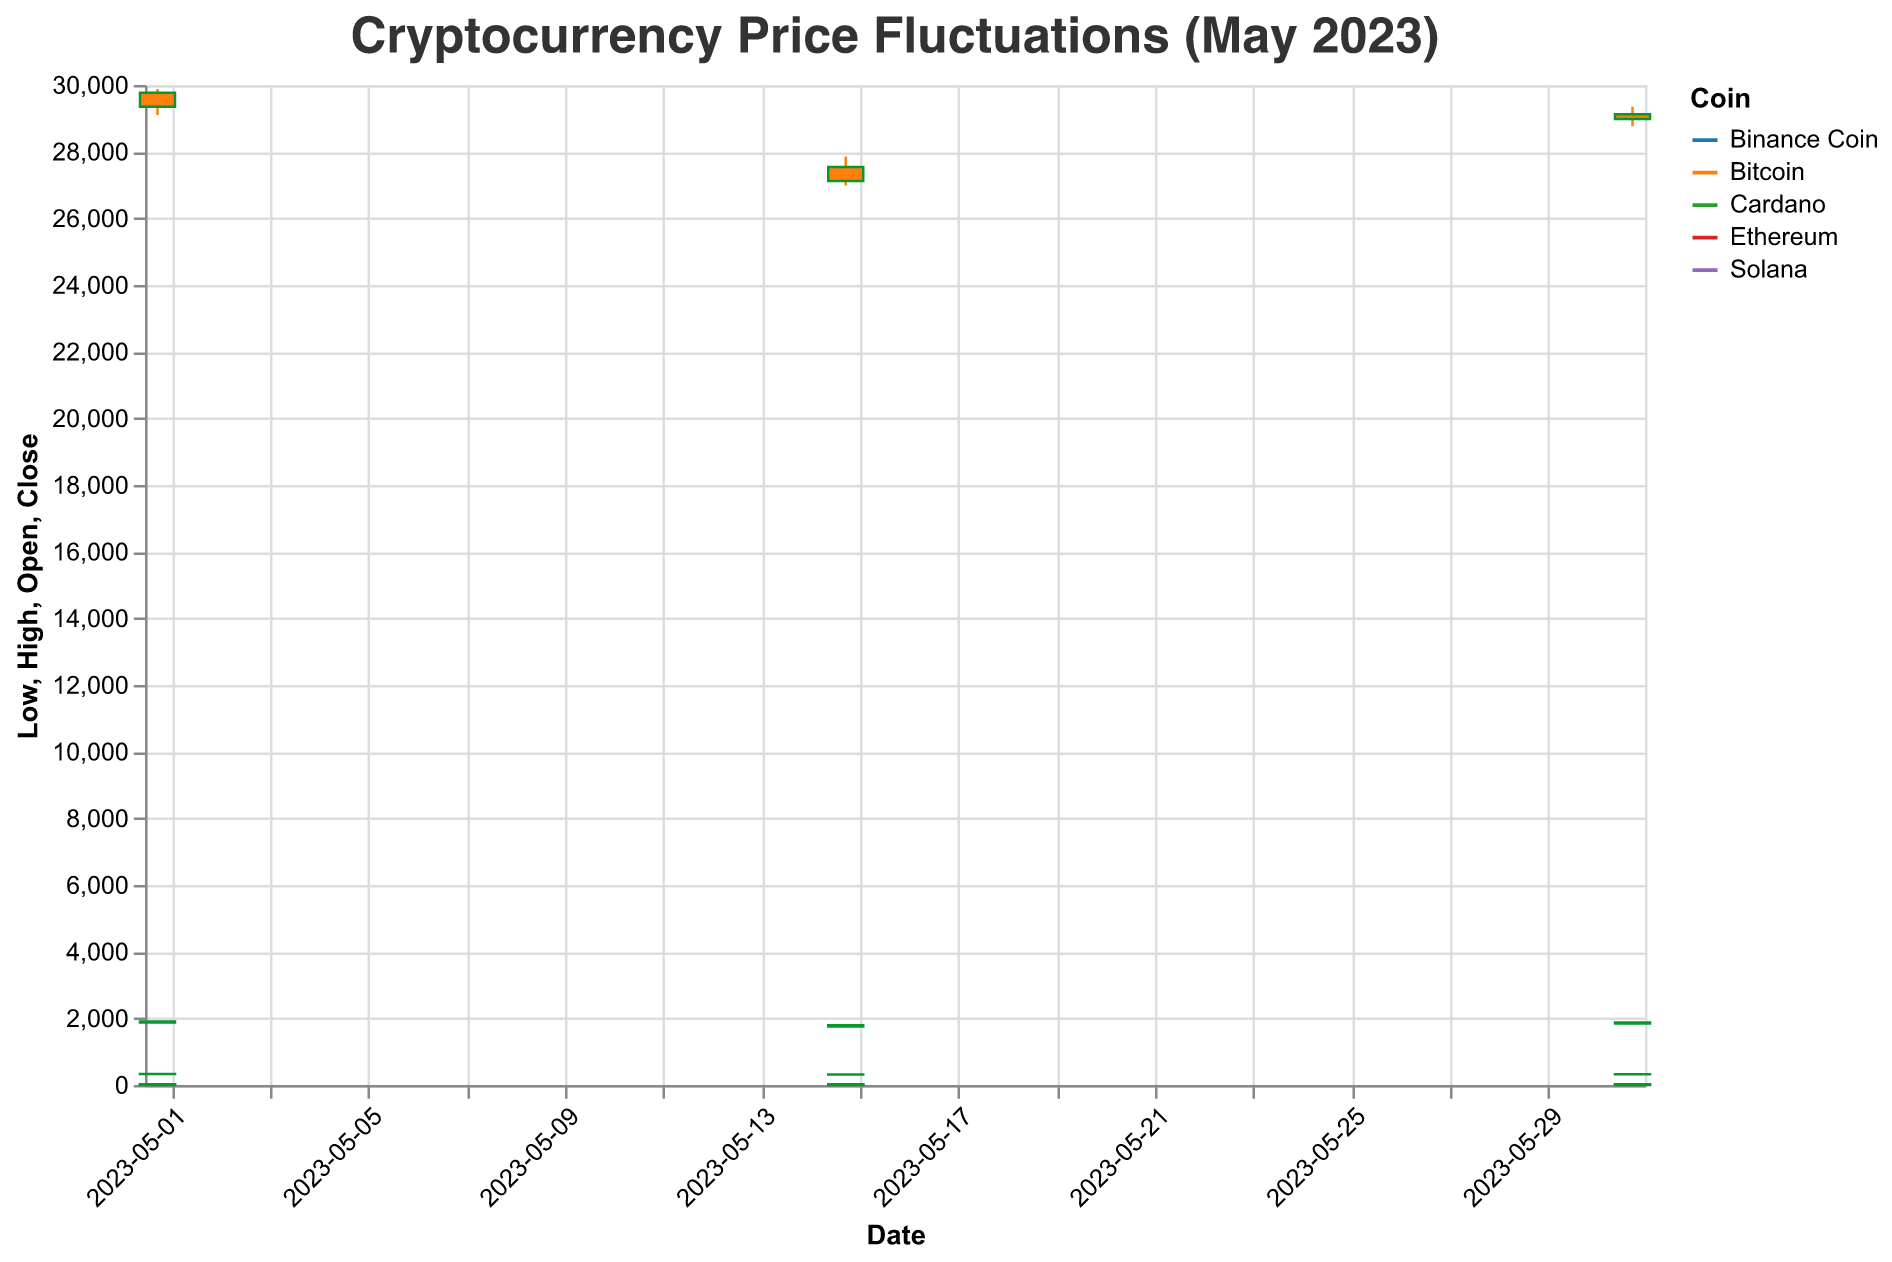What's the highest closing price of Bitcoin in May 2023? To find this, look for the highest "Close" value for Bitcoin across all the dates. Among the given values, the highest closing price of Bitcoin is 29765.21 on 2023-05-01.
Answer: 29765.21 Which coin had the highest price fluctuation on 2023-05-31? Price fluctuation is calculated as the difference between the High and Low values for each coin. Calculate this difference for all coins on 2023-05-31 and compare them. Bitcoin had the highest fluctuation with a difference of (29345.67 - 28765.43) = 580.24.
Answer: Bitcoin What was the opening price of Ethereum on 2023-05-15? Refer to the "Open" value for Ethereum on the date 2023-05-15. The opening price is 1756.78.
Answer: 1756.78 Which coin showed an increase in closing price from 2023-05-15 to 2023-05-31? Check the closing prices of each coin on both dates and see which ones increased. Bitcoin (27543.21 to 29123.45), Ethereum (1789.45 to 1876.54), and Binance Coin (315.23 to 324.98) increased in closing price.
Answer: Bitcoin, Ethereum, Binance Coin Between which two dates did Bitcoin's closing price drop the most in May 2023? To determine this, calculate the change in closing prices between consecutive dates for Bitcoin. The largest drop occurred from 2023-05-01 (29765.21) to 2023-05-15 (27543.21), a decrease of (29765.21 - 27543.21) = 2222.00.
Answer: 2023-05-01 to 2023-05-15 What is the average closing price of Solana over the three given dates in May 2023? Add the closing prices of Solana for the three dates and divide by the number of dates. (22.87 + 21.12 + 22.45) / 3 = 21.48.
Answer: 21.48 Which coin had the smallest range (difference between High and Low) on 2023-05-01? Calculate the range for each coin on 2023-05-01 by subtracting the Low value from the High value. Cardano has the smallest range: 0.4023 - 0.3876 = 0.0147.
Answer: Cardano Did Binance Coin show an increase or decrease in closing price on 2023-05-15 compared to 2023-05-01? Compare the closing prices of Binance Coin on 2023-05-01 (331.54) and on 2023-05-15 (315.23). It showed a decrease: 315.23 is lower than 331.54.
Answer: Decrease What is the overall trend of Bitcoin’s closing price in May 2023? Observe the closing prices of Bitcoin over the given dates: 29765.21 (2023-05-01), 27543.21 (2023-05-15), and 29123.45 (2023-05-31). The price decreases initially and then increases, suggesting a decline followed by a partial recovery.
Answer: Decline followed by partial recovery 